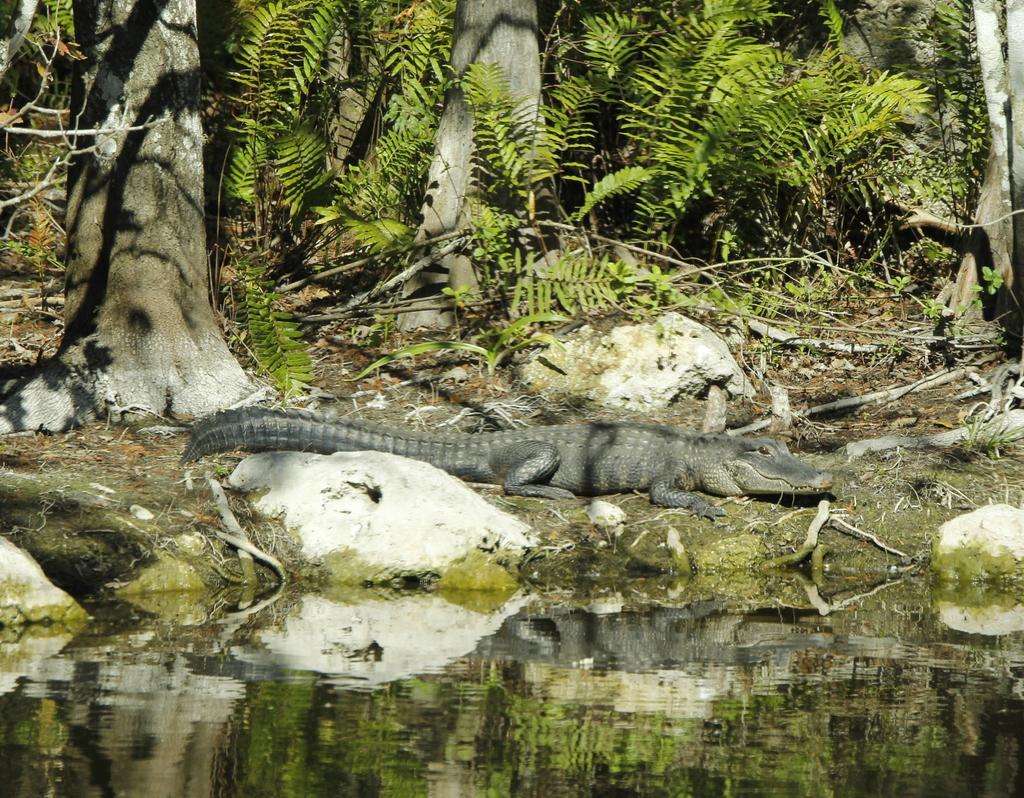In one or two sentences, can you explain what this image depicts? In this image I can see water in the front. I can also see a crocodile on the ground and few trees. 